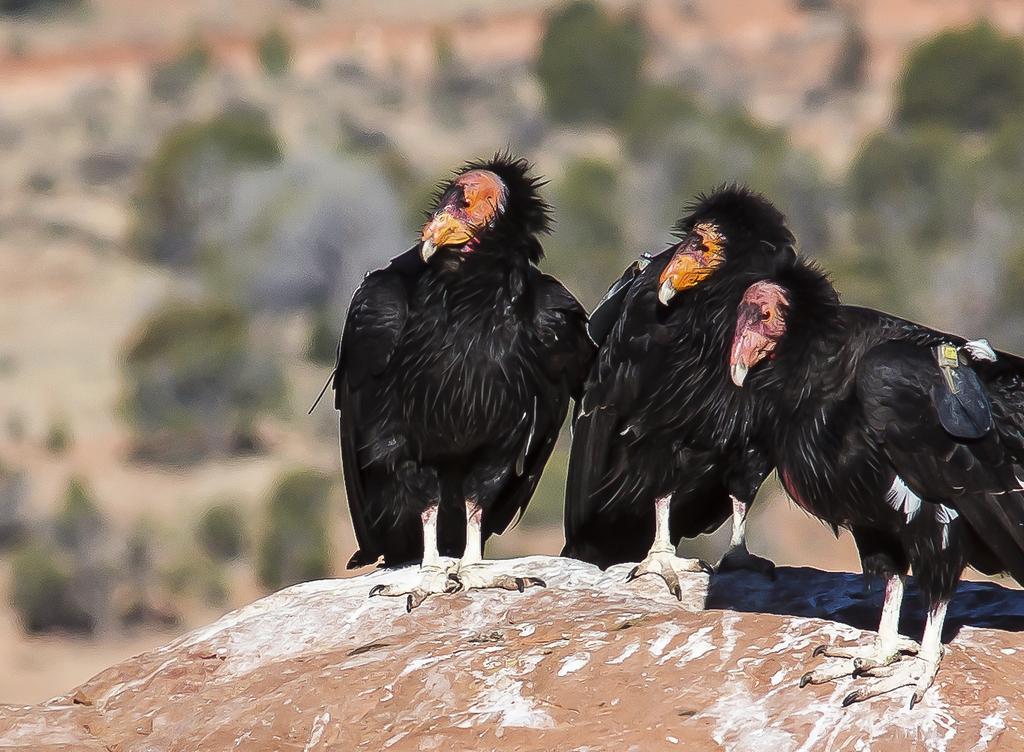How would you summarize this image in a sentence or two? In this image in the front there are birds and the background is blurry. 